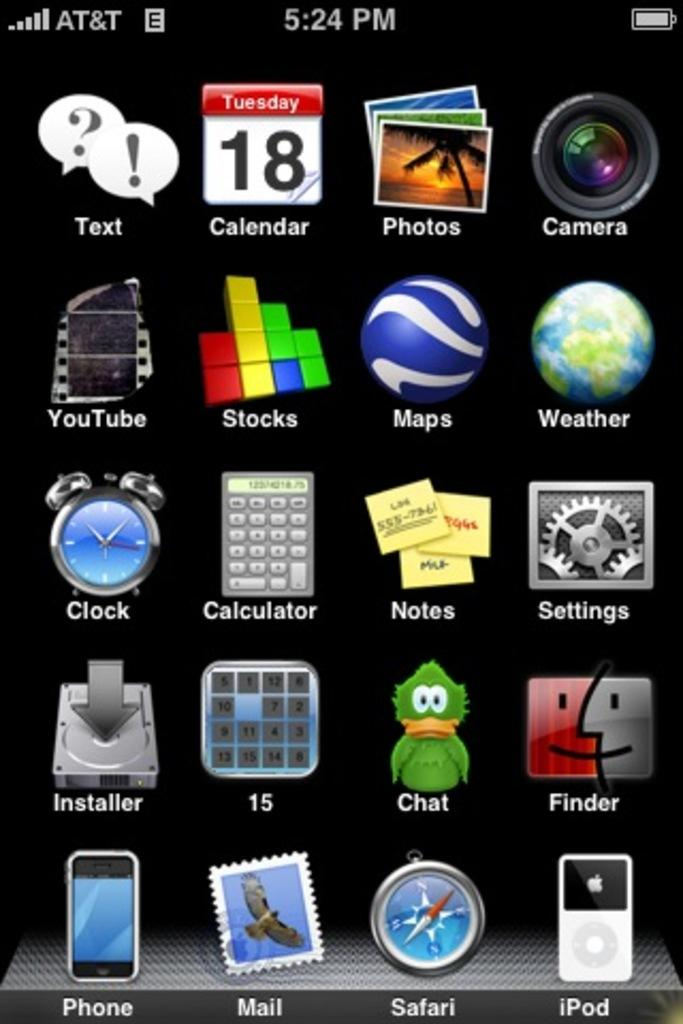<image>
Provide a brief description of the given image. A screenshot from an AT&T smart phone showing it to be 5:24 pm. 